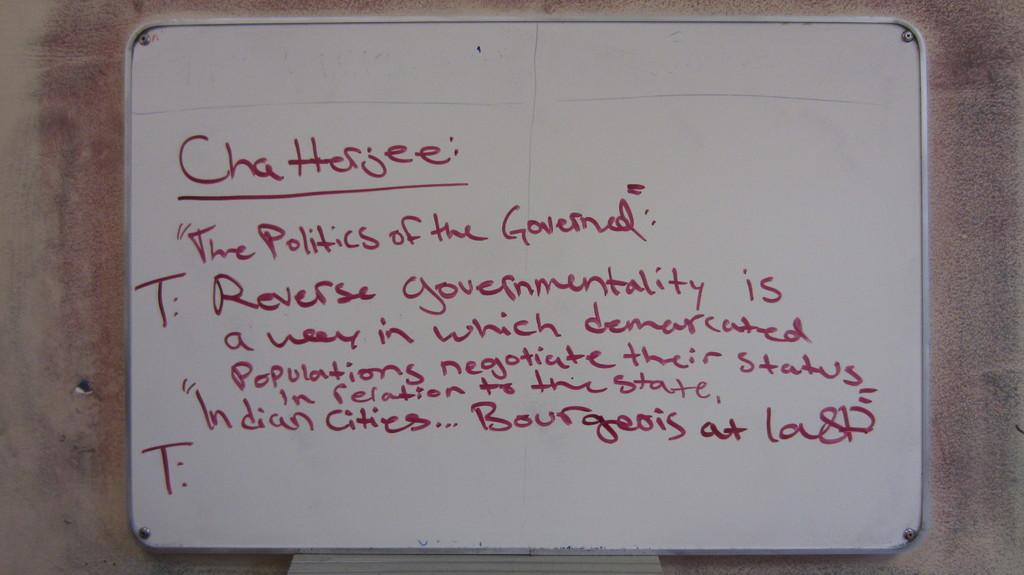Provide a one-sentence caption for the provided image. notes on Chatterjee's The polticis of the Governed". 